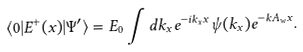<formula> <loc_0><loc_0><loc_500><loc_500>\langle 0 | E ^ { + } ( x ) | \Psi ^ { \prime } \rangle = E _ { 0 } \int d k _ { x } e ^ { - i k _ { x } x } \psi ( k _ { x } ) e ^ { - k A _ { w } x } .</formula> 